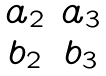Convert formula to latex. <formula><loc_0><loc_0><loc_500><loc_500>\begin{matrix} a _ { 2 } & a _ { 3 } \\ b _ { 2 } & b _ { 3 } \end{matrix}</formula> 